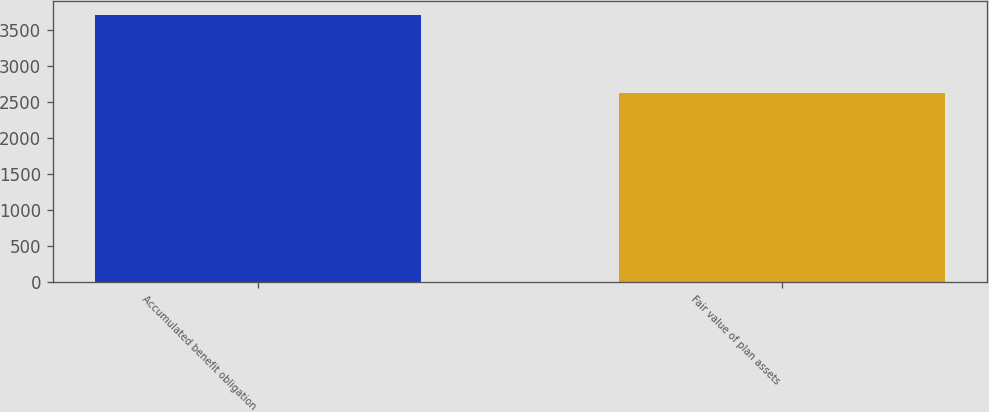<chart> <loc_0><loc_0><loc_500><loc_500><bar_chart><fcel>Accumulated benefit obligation<fcel>Fair value of plan assets<nl><fcel>3715<fcel>2633<nl></chart> 